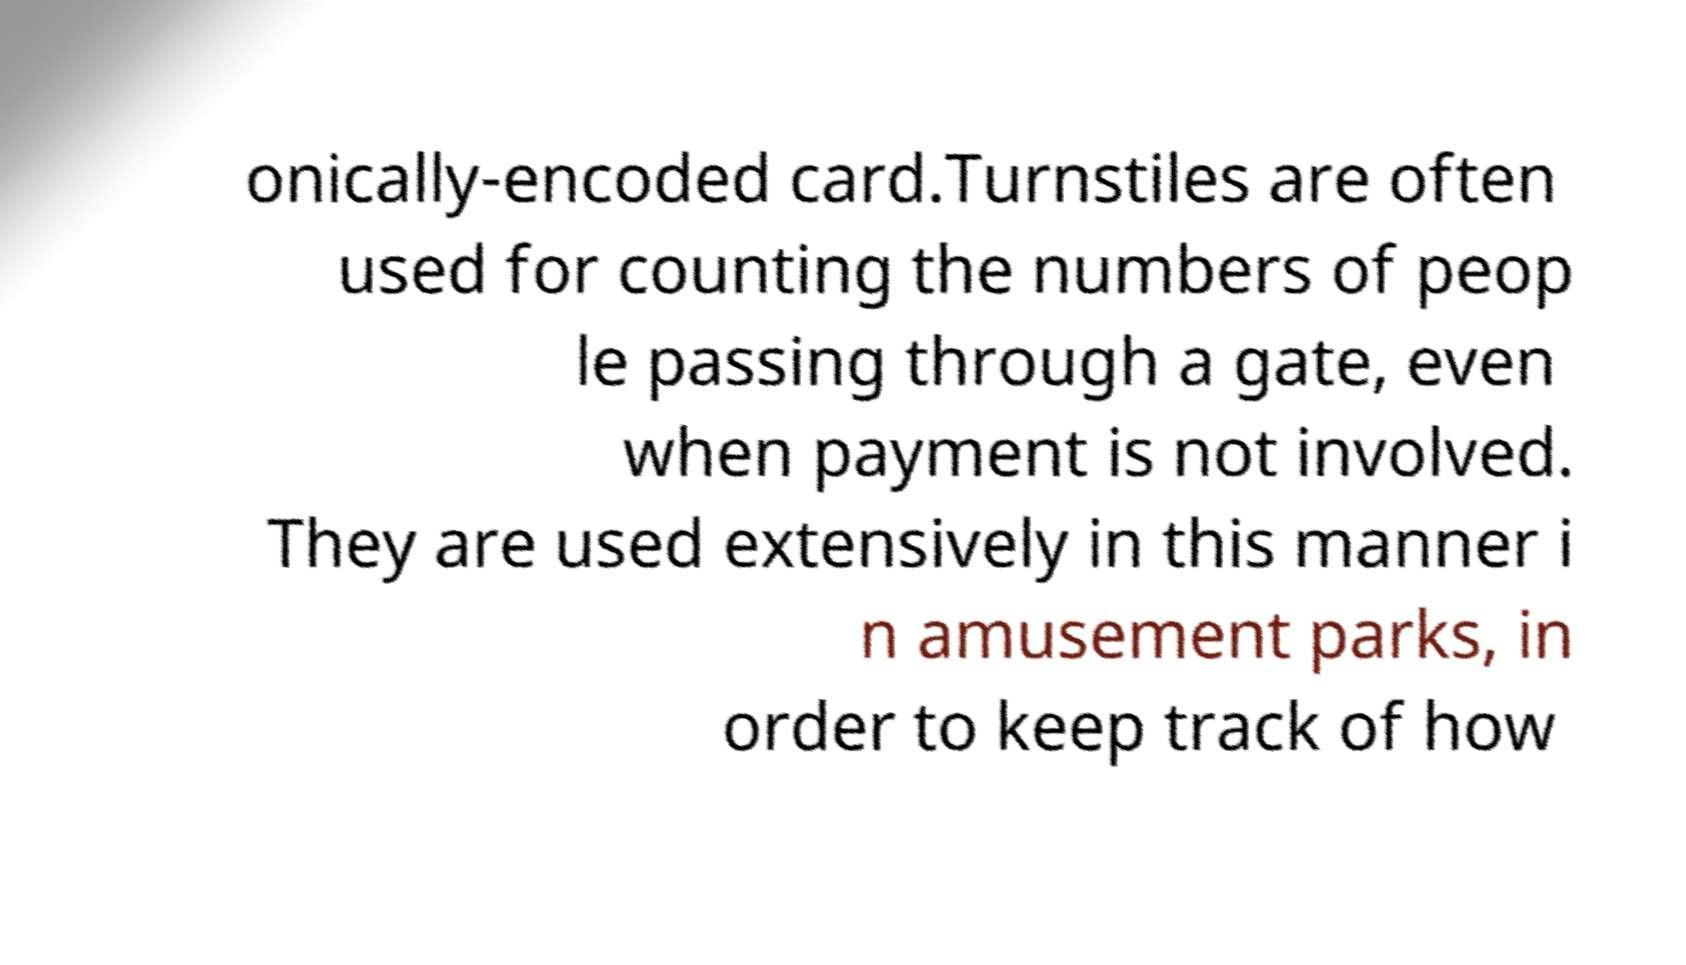Can you read and provide the text displayed in the image?This photo seems to have some interesting text. Can you extract and type it out for me? onically-encoded card.Turnstiles are often used for counting the numbers of peop le passing through a gate, even when payment is not involved. They are used extensively in this manner i n amusement parks, in order to keep track of how 